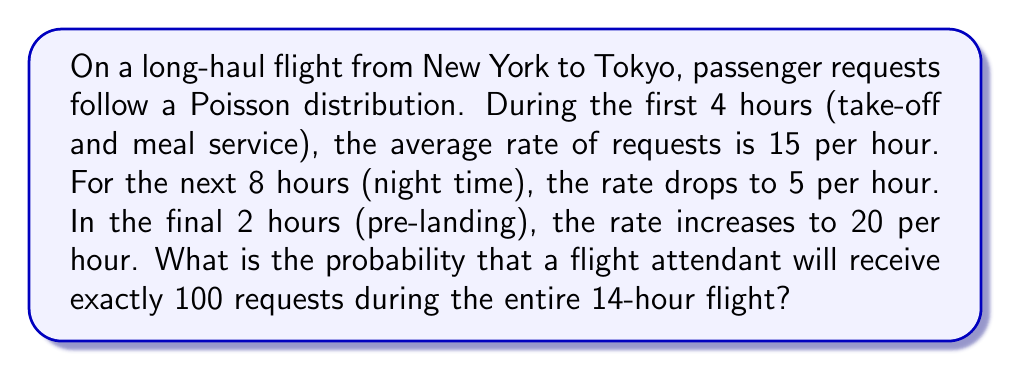Could you help me with this problem? Let's approach this step-by-step:

1) First, we need to calculate the expected number of requests for each phase of the flight:
   - First 4 hours: $\lambda_1 = 4 \times 15 = 60$
   - Next 8 hours: $\lambda_2 = 8 \times 5 = 40$
   - Final 2 hours: $\lambda_3 = 2 \times 20 = 40$

2) The total expected number of requests for the entire flight is:
   $\lambda_{total} = \lambda_1 + \lambda_2 + \lambda_3 = 60 + 40 + 40 = 140$

3) Since the requests in each phase are independent and follow a Poisson distribution, the total number of requests for the entire flight also follows a Poisson distribution with parameter $\lambda_{total} = 140$.

4) The probability of exactly $k$ events in a Poisson distribution is given by:

   $$P(X = k) = \frac{e^{-\lambda} \lambda^k}{k!}$$

5) In this case, we want $P(X = 100)$ with $\lambda = 140$:

   $$P(X = 100) = \frac{e^{-140} 140^{100}}{100!}$$

6) Using a calculator or computer (due to the large numbers involved):

   $$P(X = 100) \approx 0.0013$$

Thus, the probability of receiving exactly 100 requests during the entire flight is approximately 0.0013 or 0.13%.
Answer: 0.0013 